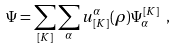<formula> <loc_0><loc_0><loc_500><loc_500>\Psi = \sum _ { [ K ] } \sum _ { \alpha } u ^ { \alpha } _ { [ K ] } ( \rho ) \Psi _ { \alpha } ^ { [ K ] } \ ,</formula> 